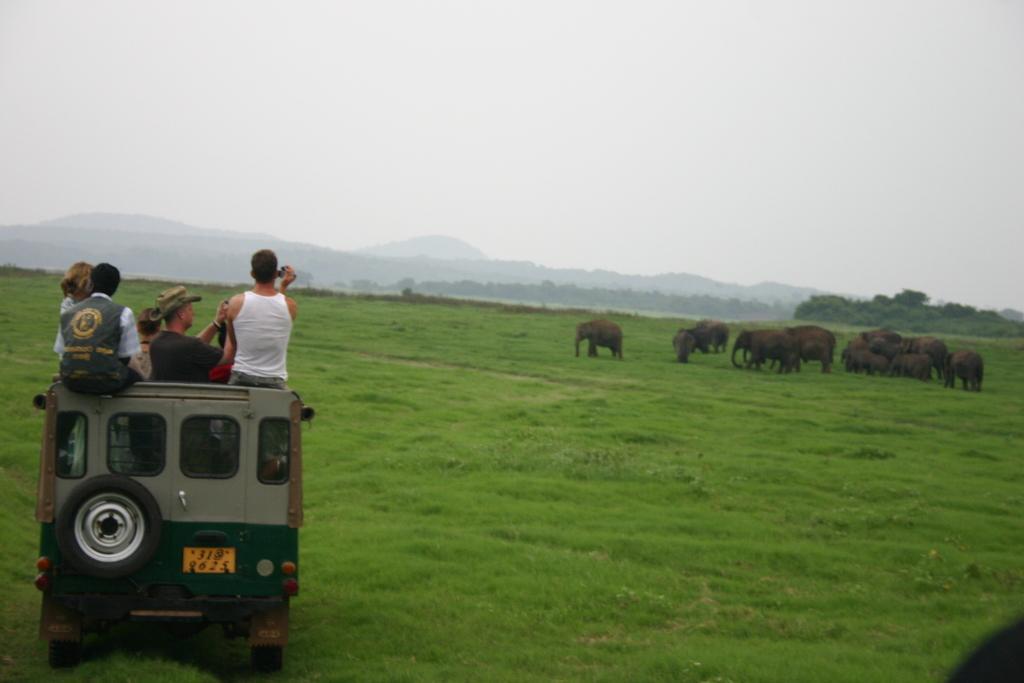Please provide a concise description of this image. In this image we can see some people travelling in a vehicle. Two persons are taking pictures with a camera. On the backside we can see some elephants, grass, trees, hills and the sky. 